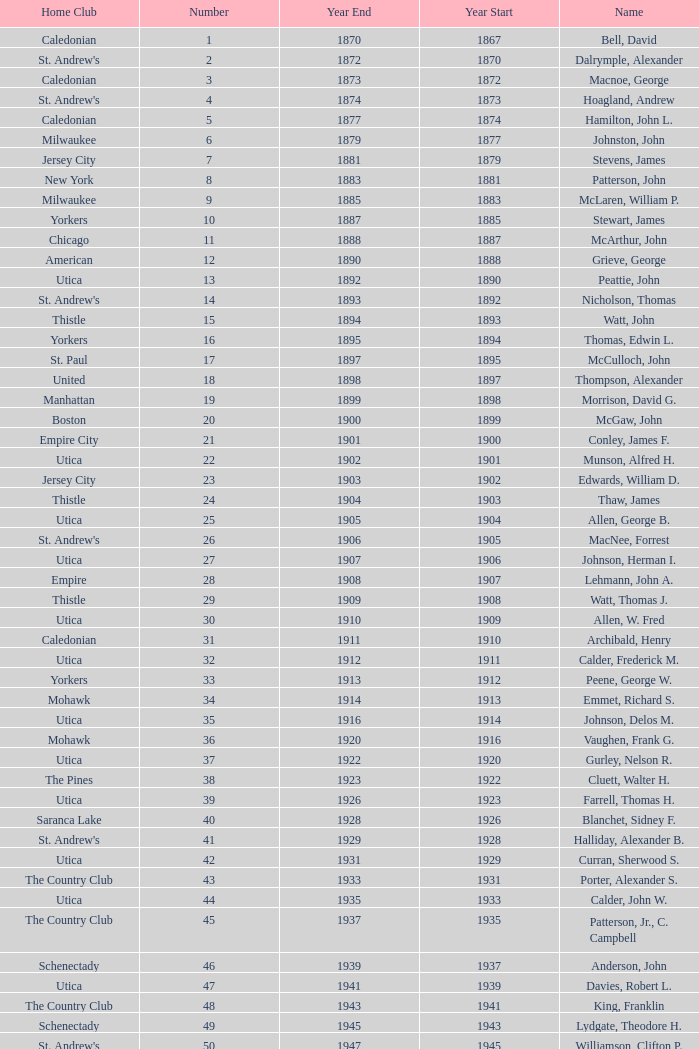Which Number has a Home Club of broomstones, and a Year End smaller than 1999? None. 